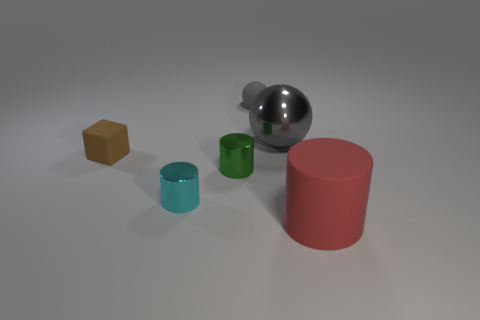Subtract all tiny metal cylinders. How many cylinders are left? 1 Add 3 cyan metallic cylinders. How many objects exist? 9 Subtract all blocks. How many objects are left? 5 Subtract all small green cylinders. Subtract all large cyan rubber cylinders. How many objects are left? 5 Add 4 shiny cylinders. How many shiny cylinders are left? 6 Add 2 red metallic balls. How many red metallic balls exist? 2 Subtract 0 gray cubes. How many objects are left? 6 